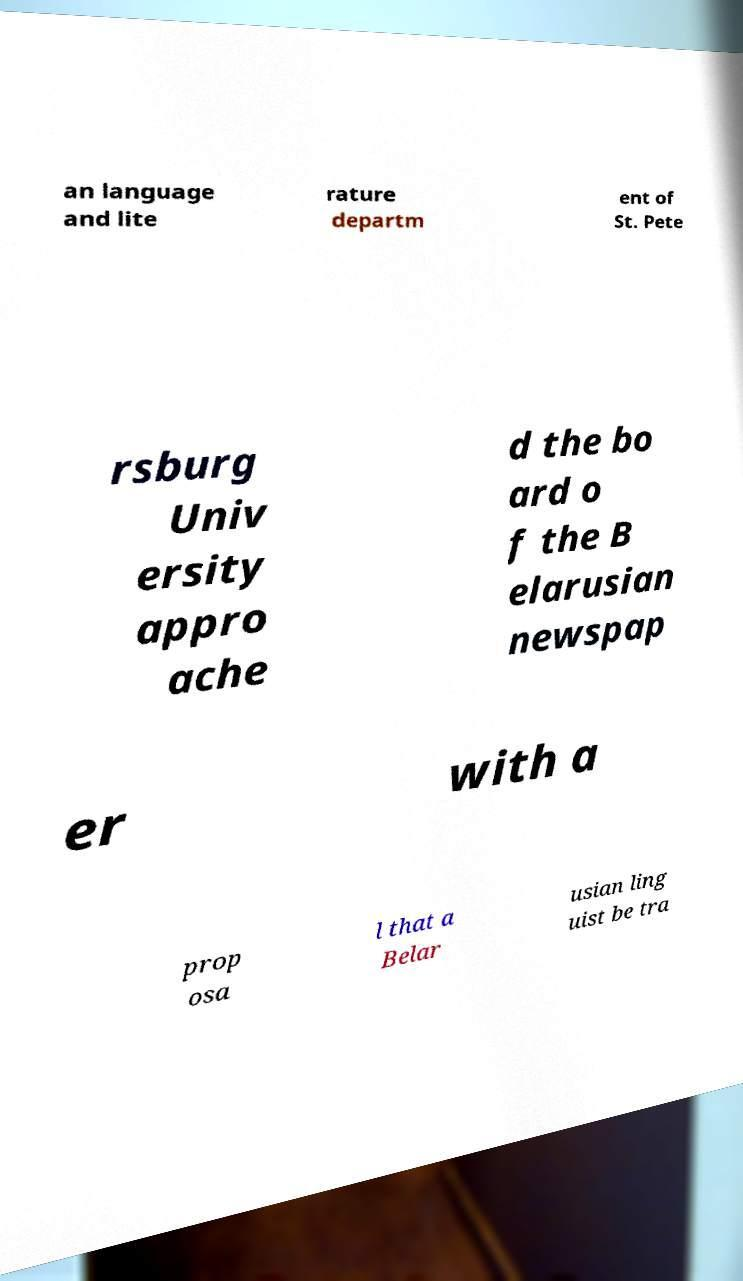What messages or text are displayed in this image? I need them in a readable, typed format. an language and lite rature departm ent of St. Pete rsburg Univ ersity appro ache d the bo ard o f the B elarusian newspap er with a prop osa l that a Belar usian ling uist be tra 